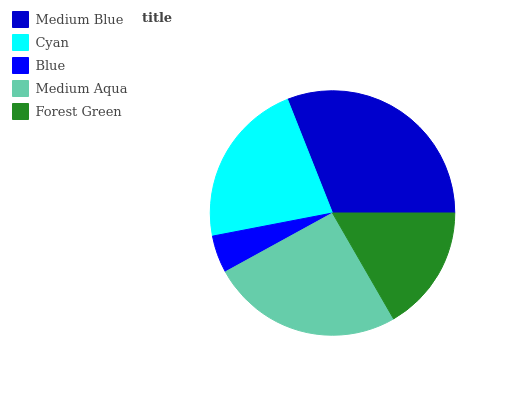Is Blue the minimum?
Answer yes or no. Yes. Is Medium Blue the maximum?
Answer yes or no. Yes. Is Cyan the minimum?
Answer yes or no. No. Is Cyan the maximum?
Answer yes or no. No. Is Medium Blue greater than Cyan?
Answer yes or no. Yes. Is Cyan less than Medium Blue?
Answer yes or no. Yes. Is Cyan greater than Medium Blue?
Answer yes or no. No. Is Medium Blue less than Cyan?
Answer yes or no. No. Is Cyan the high median?
Answer yes or no. Yes. Is Cyan the low median?
Answer yes or no. Yes. Is Medium Aqua the high median?
Answer yes or no. No. Is Blue the low median?
Answer yes or no. No. 